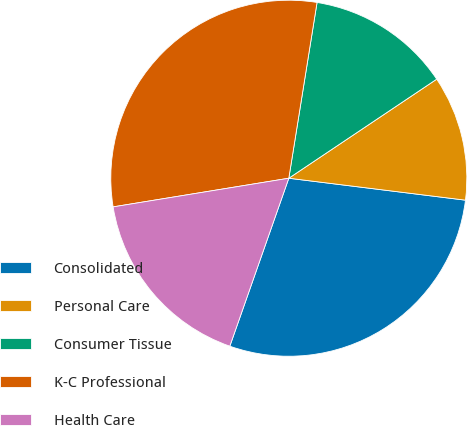Convert chart to OTSL. <chart><loc_0><loc_0><loc_500><loc_500><pie_chart><fcel>Consolidated<fcel>Personal Care<fcel>Consumer Tissue<fcel>K-C Professional<fcel>Health Care<nl><fcel>28.41%<fcel>11.36%<fcel>13.07%<fcel>30.11%<fcel>17.05%<nl></chart> 